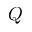Convert formula to latex. <formula><loc_0><loc_0><loc_500><loc_500>Q</formula> 